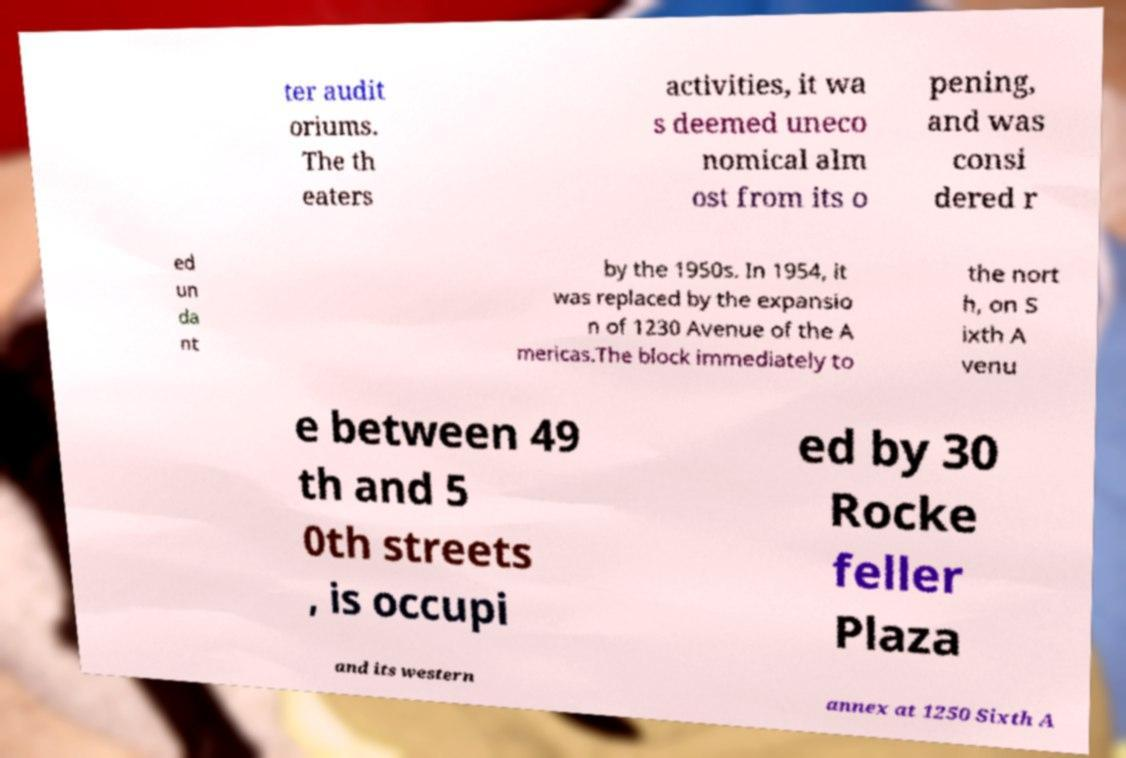Could you extract and type out the text from this image? ter audit oriums. The th eaters activities, it wa s deemed uneco nomical alm ost from its o pening, and was consi dered r ed un da nt by the 1950s. In 1954, it was replaced by the expansio n of 1230 Avenue of the A mericas.The block immediately to the nort h, on S ixth A venu e between 49 th and 5 0th streets , is occupi ed by 30 Rocke feller Plaza and its western annex at 1250 Sixth A 